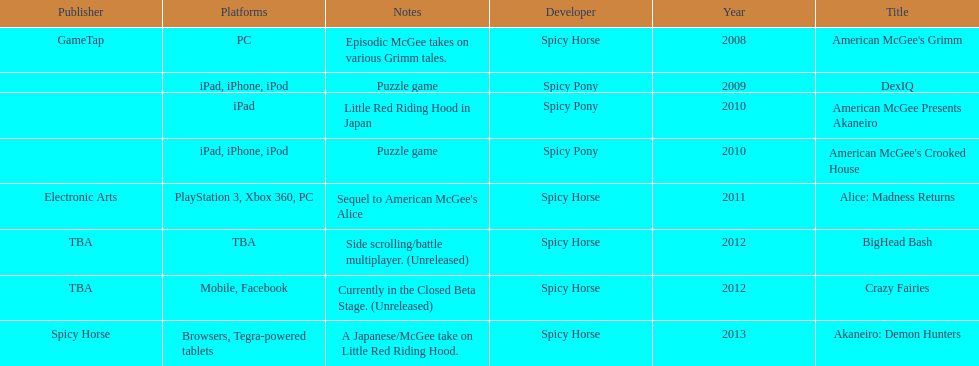Which spicy horse titles are shown? American McGee's Grimm, DexIQ, American McGee Presents Akaneiro, American McGee's Crooked House, Alice: Madness Returns, BigHead Bash, Crazy Fairies, Akaneiro: Demon Hunters. Of those, which are for the ipad? DexIQ, American McGee Presents Akaneiro, American McGee's Crooked House. Which of those are not for the iphone or ipod? American McGee Presents Akaneiro. 